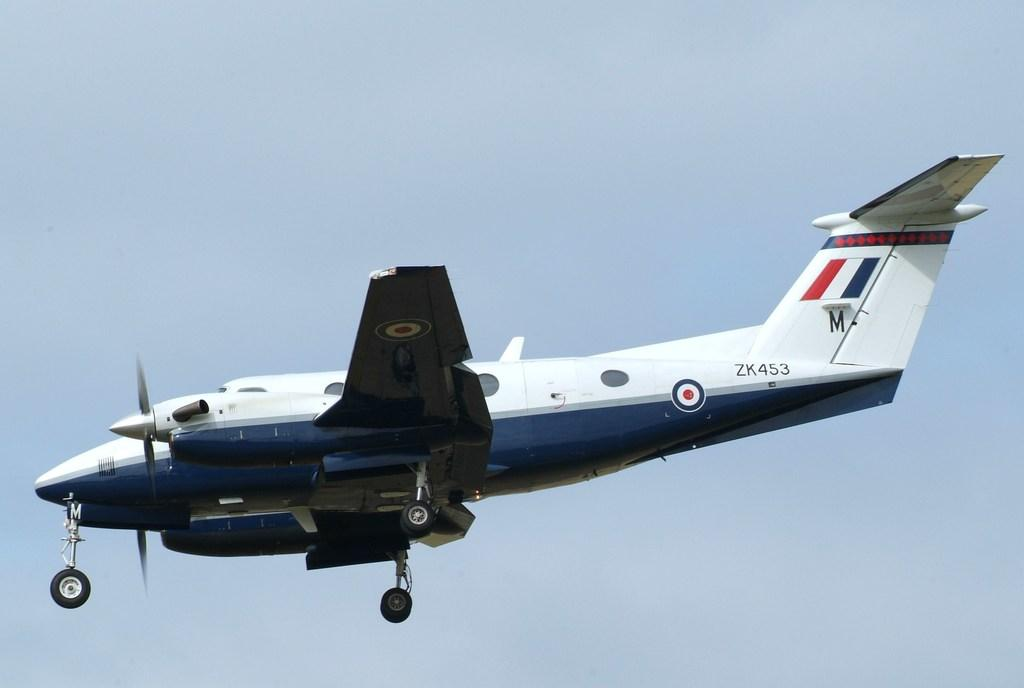<image>
Create a compact narrative representing the image presented. AIrplane number ZK453 is flying through the sky. 